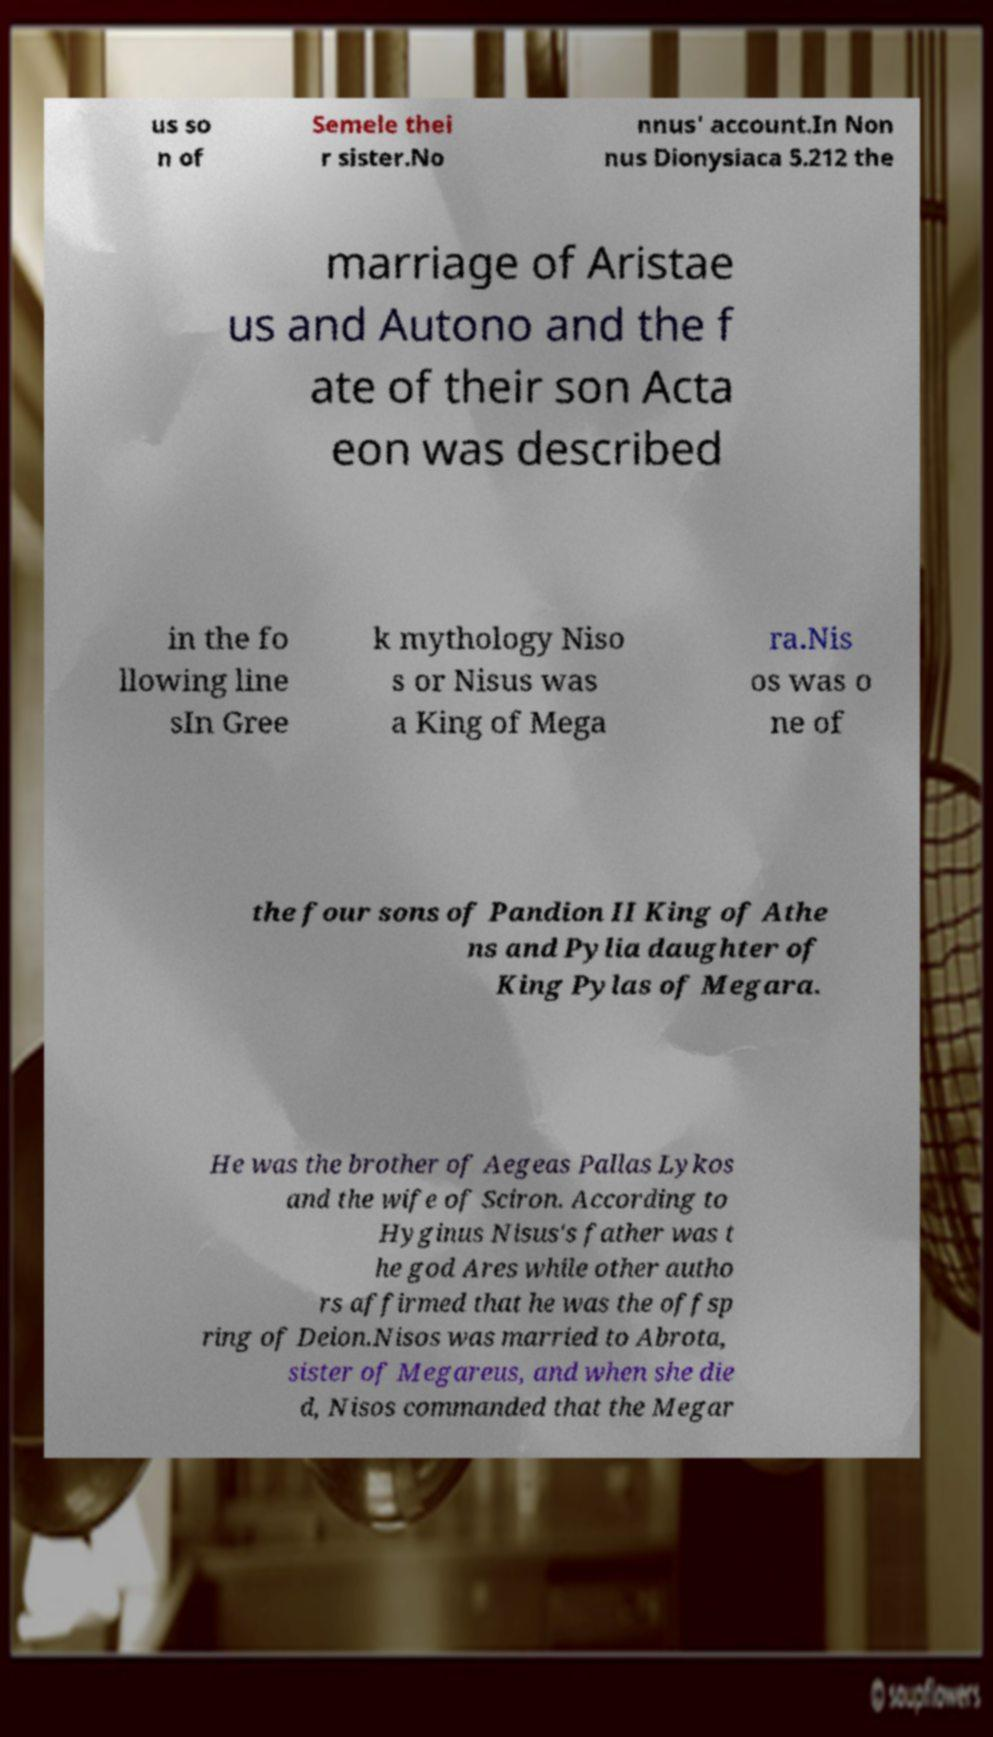I need the written content from this picture converted into text. Can you do that? us so n of Semele thei r sister.No nnus' account.In Non nus Dionysiaca 5.212 the marriage of Aristae us and Autono and the f ate of their son Acta eon was described in the fo llowing line sIn Gree k mythology Niso s or Nisus was a King of Mega ra.Nis os was o ne of the four sons of Pandion II King of Athe ns and Pylia daughter of King Pylas of Megara. He was the brother of Aegeas Pallas Lykos and the wife of Sciron. According to Hyginus Nisus's father was t he god Ares while other autho rs affirmed that he was the offsp ring of Deion.Nisos was married to Abrota, sister of Megareus, and when she die d, Nisos commanded that the Megar 